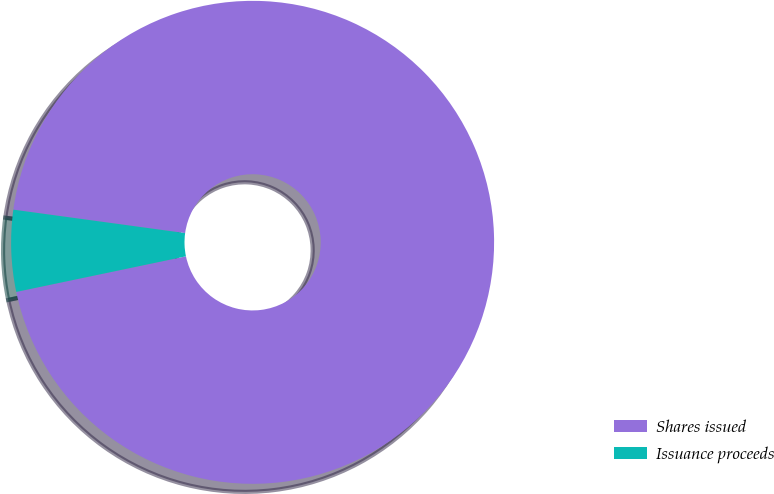Convert chart. <chart><loc_0><loc_0><loc_500><loc_500><pie_chart><fcel>Shares issued<fcel>Issuance proceeds<nl><fcel>94.55%<fcel>5.45%<nl></chart> 